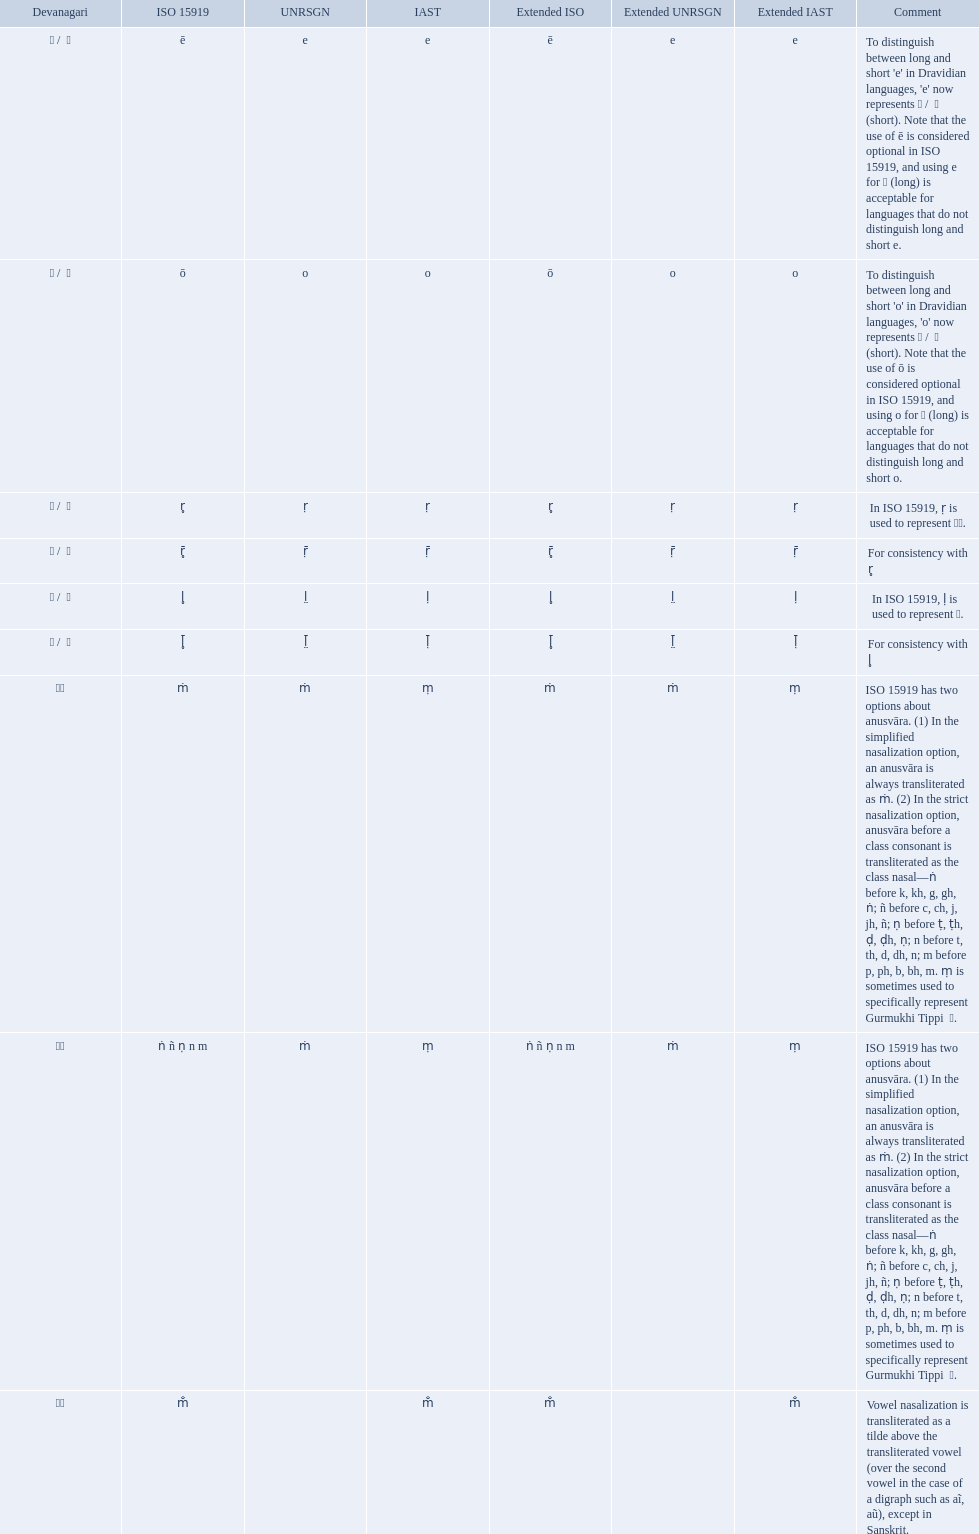What is the total number of translations? 8. 